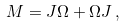Convert formula to latex. <formula><loc_0><loc_0><loc_500><loc_500>M = J \Omega + \Omega J \, ,</formula> 